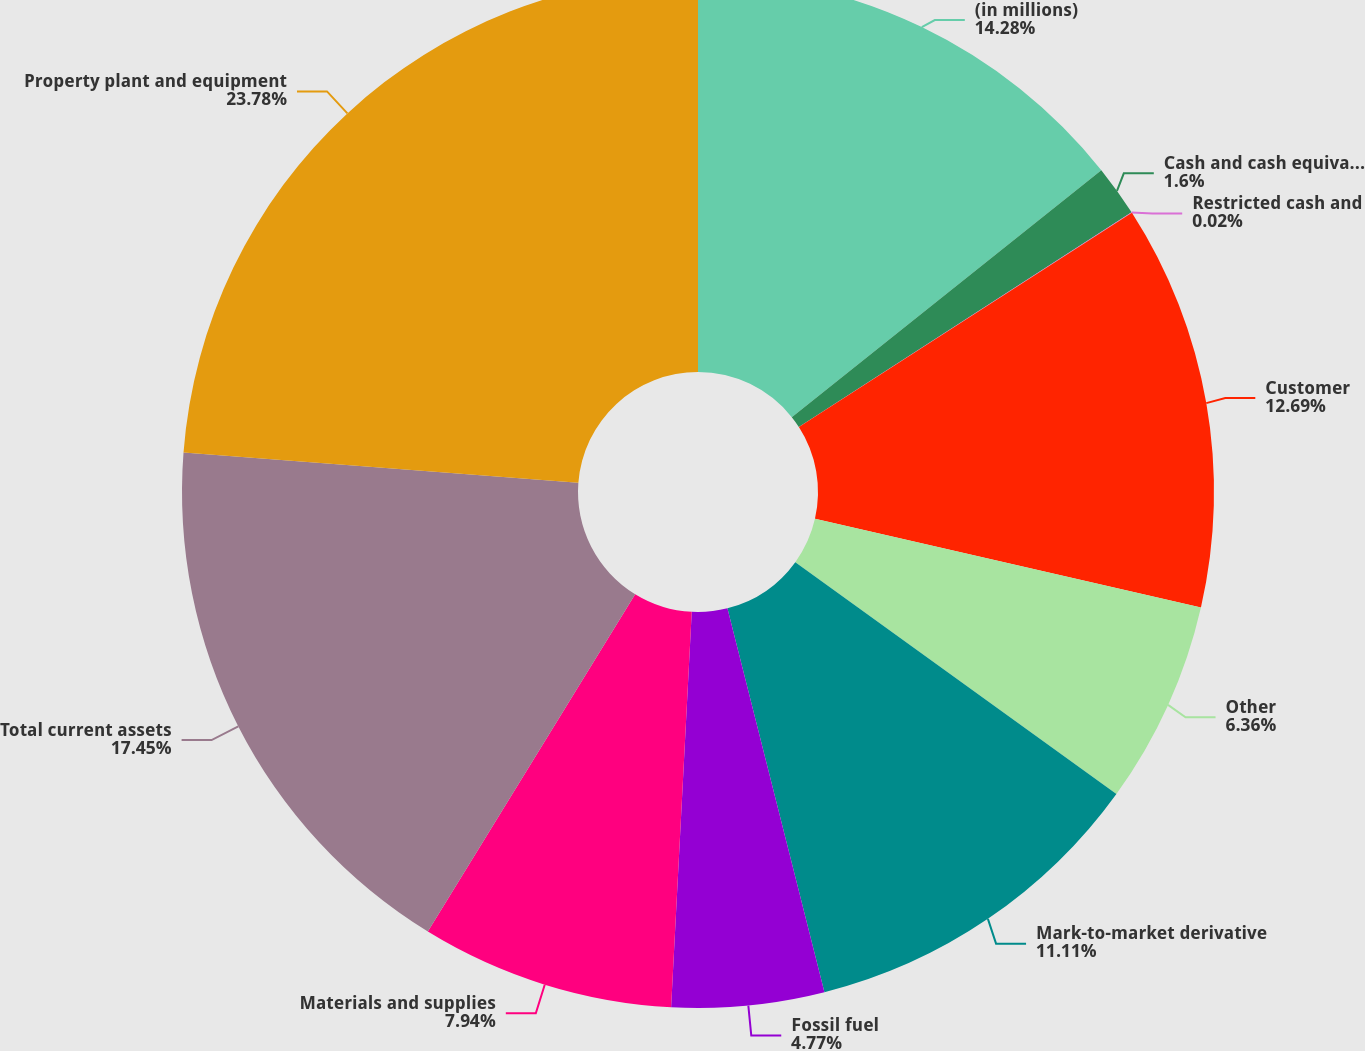Convert chart. <chart><loc_0><loc_0><loc_500><loc_500><pie_chart><fcel>(in millions)<fcel>Cash and cash equivalents<fcel>Restricted cash and<fcel>Customer<fcel>Other<fcel>Mark-to-market derivative<fcel>Fossil fuel<fcel>Materials and supplies<fcel>Total current assets<fcel>Property plant and equipment<nl><fcel>14.28%<fcel>1.6%<fcel>0.02%<fcel>12.69%<fcel>6.36%<fcel>11.11%<fcel>4.77%<fcel>7.94%<fcel>17.45%<fcel>23.78%<nl></chart> 